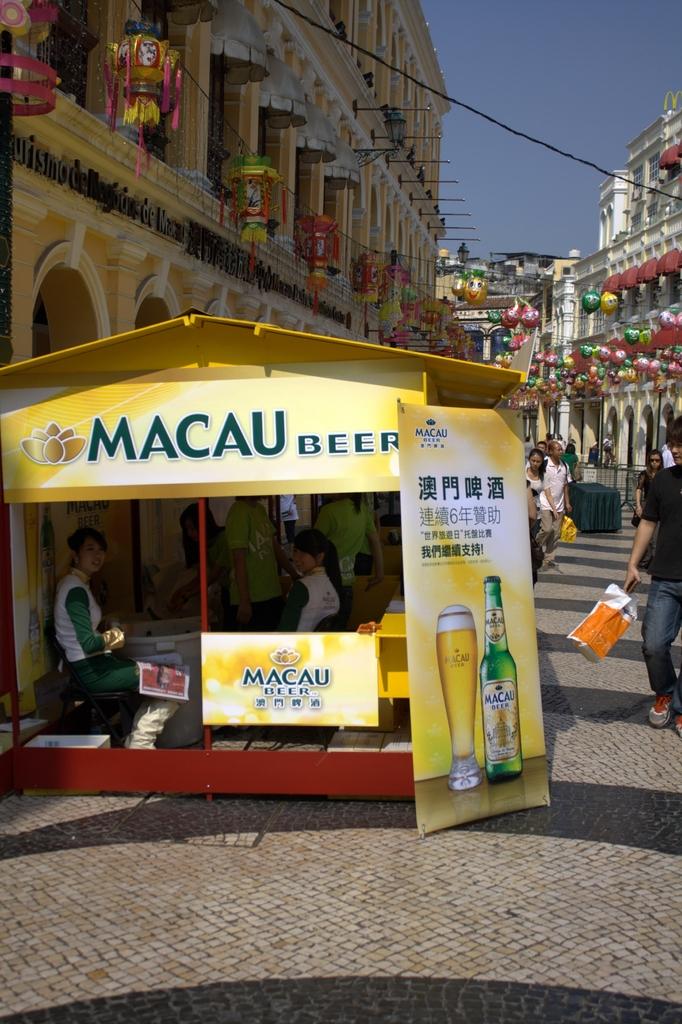What is the stand for?
Ensure brevity in your answer.  Macau beer. Whats the beer being advertised?
Give a very brief answer. Macau. 